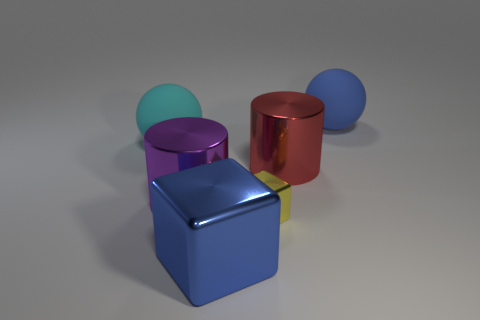Add 1 big cyan matte spheres. How many objects exist? 7 Subtract all balls. How many objects are left? 4 Subtract 1 spheres. How many spheres are left? 1 Add 3 small yellow blocks. How many small yellow blocks are left? 4 Add 4 large brown shiny cylinders. How many large brown shiny cylinders exist? 4 Subtract all blue blocks. How many blocks are left? 1 Subtract 0 brown cylinders. How many objects are left? 6 Subtract all green cylinders. Subtract all gray cubes. How many cylinders are left? 2 Subtract all blue cylinders. How many purple balls are left? 0 Subtract all large purple metallic cylinders. Subtract all large cyan matte spheres. How many objects are left? 4 